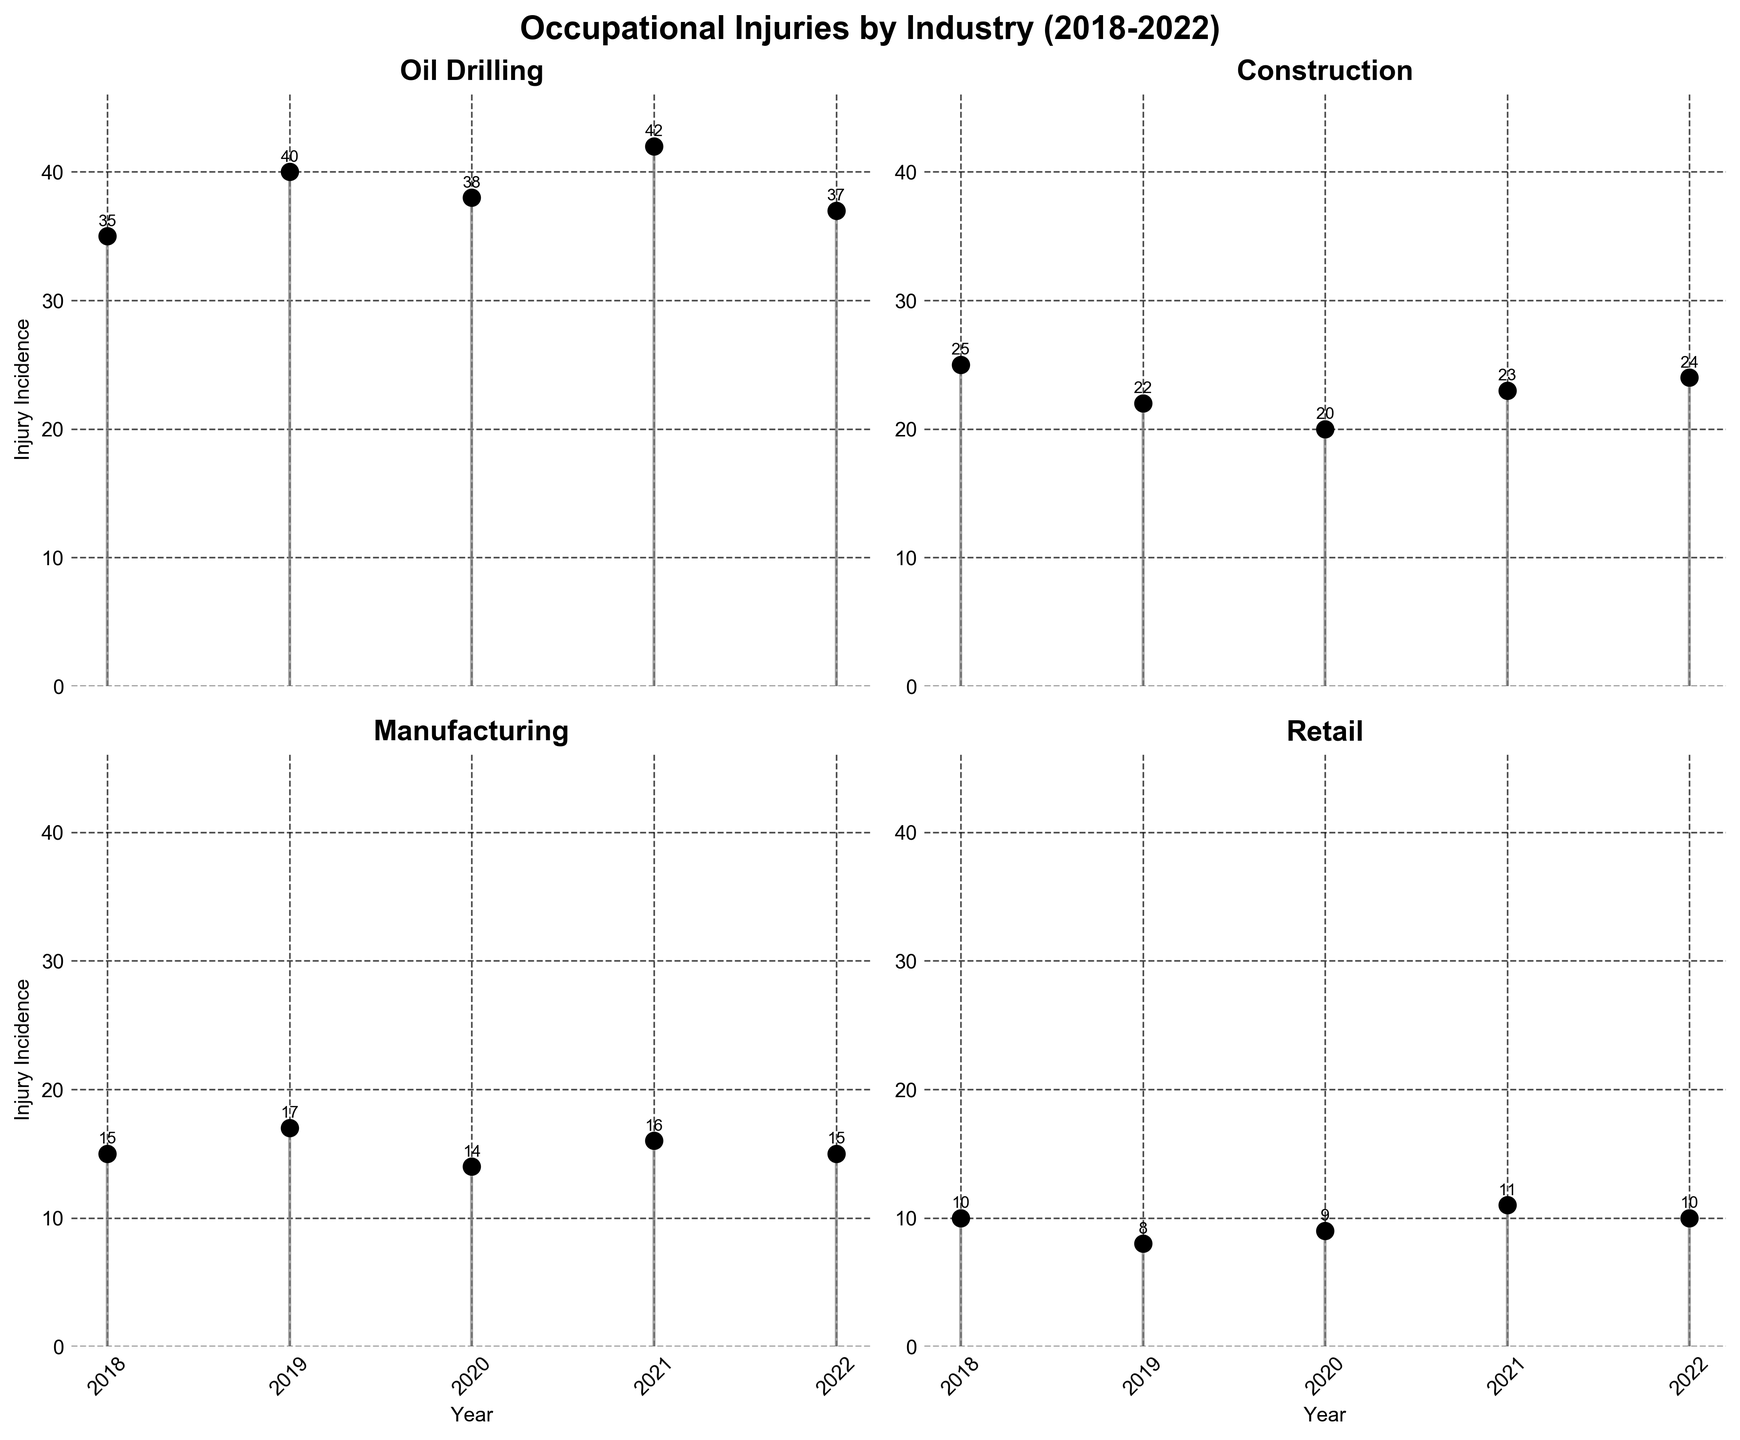What is the title of the figure? The title is at the top of the figure and reads 'Occupational Injuries by Industry (2018-2022)'.
Answer: Occupational Injuries by Industry (2018-2022) How many subplots are in the figure? There are 4 subplots arranged in a 2x2 grid, each representing a different industry.
Answer: 4 Which industry had the highest incidence of occupational injuries in 2019? Looking at the subplot for 2019, the 'Oil Drilling' industry shows the highest injury incidence with 40 cases.
Answer: Oil Drilling What is the general trend of occupational injuries in the Oil Drilling industry from 2018 to 2022? The trend can be seen by observing the marker points of the 'Oil Drilling' subplot: starting at 35 in 2018, peaking at 42 in 2021, and then decreasing to 37 in 2022.
Answer: Peak in 2021 In which year did the Retail industry see a slight increase in occupational injuries? The Retail subplot shows markers, where there is a slight increase from 8 in 2019 to 9 in 2020.
Answer: 2020 What is the average number of occupational injuries across all industries in 2019? Summing the injury incidences for 2019: (40+22+17+8) = 87, and then dividing by the 4 industries gives the average: 87/4 = 21.75.
Answer: 21.75 Compare the number of occupational injuries in Manufacturing in 2020 with Construction in the same year. Which one is higher? The subplot shows 14 injuries for Manufacturing and 20 for Construction in 2020. Construction is higher.
Answer: Construction Does the Manufacturing industry show any significant changes in occupational injuries over the years? Observing the Manufacturing subplot, the incidence fluctuates slightly but remains between 14 and 17, indicating no significant changes.
Answer: No significant changes Which industry consistently had the lowest number of occupational injuries from 2018 to 2022? Looking at all subplots, the Retail industry consistently has the lowest injury numbers compared to other industries each year.
Answer: Retail In which year did the total number of occupational injuries in all industries peak? Summing the injury incidences for each year: 
2018:(35+25+15+10)=85, 
2019:(40+22+17+8)=87, 
2020:(38+20+14+9)=81, 
2021:(42+23+16+11)=92, 
2022:(37+24+15+10)=86, the peak is in 2021 with 92 injuries.
Answer: 2021 